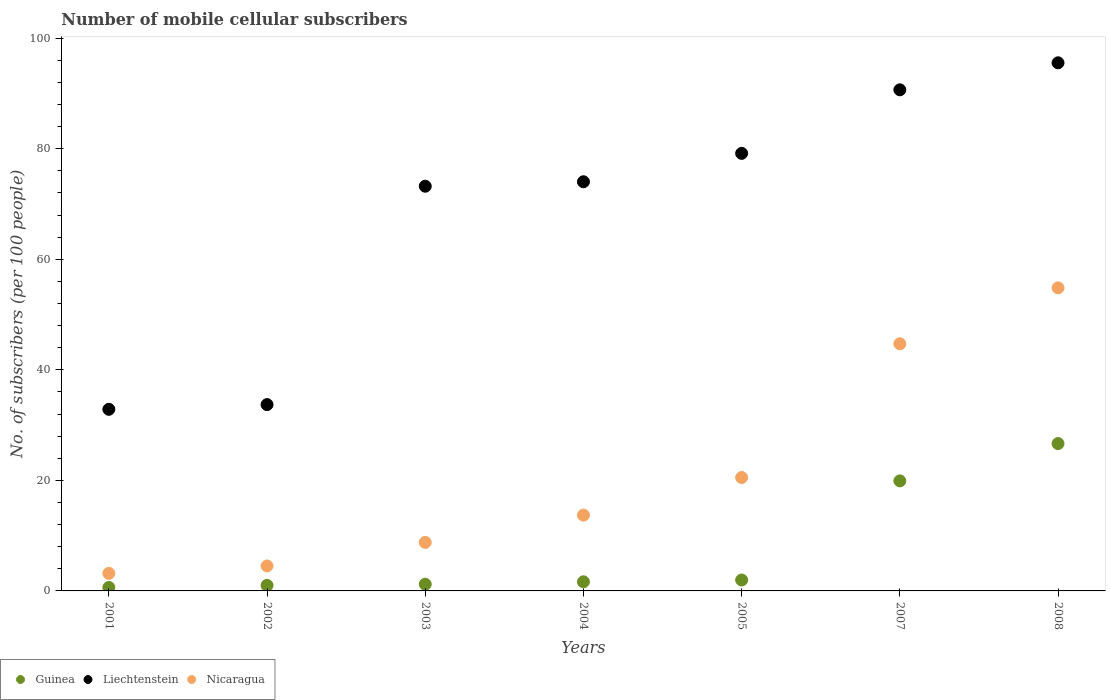How many different coloured dotlines are there?
Keep it short and to the point. 3. What is the number of mobile cellular subscribers in Nicaragua in 2003?
Provide a succinct answer. 8.78. Across all years, what is the maximum number of mobile cellular subscribers in Nicaragua?
Keep it short and to the point. 54.83. Across all years, what is the minimum number of mobile cellular subscribers in Guinea?
Keep it short and to the point. 0.63. What is the total number of mobile cellular subscribers in Liechtenstein in the graph?
Your answer should be compact. 479.22. What is the difference between the number of mobile cellular subscribers in Liechtenstein in 2007 and that in 2008?
Provide a short and direct response. -4.89. What is the difference between the number of mobile cellular subscribers in Nicaragua in 2001 and the number of mobile cellular subscribers in Guinea in 2008?
Offer a very short reply. -23.48. What is the average number of mobile cellular subscribers in Liechtenstein per year?
Your response must be concise. 68.46. In the year 2008, what is the difference between the number of mobile cellular subscribers in Nicaragua and number of mobile cellular subscribers in Guinea?
Your answer should be very brief. 28.17. What is the ratio of the number of mobile cellular subscribers in Guinea in 2003 to that in 2007?
Your answer should be very brief. 0.06. Is the number of mobile cellular subscribers in Guinea in 2002 less than that in 2005?
Ensure brevity in your answer.  Yes. What is the difference between the highest and the second highest number of mobile cellular subscribers in Liechtenstein?
Your answer should be compact. 4.89. What is the difference between the highest and the lowest number of mobile cellular subscribers in Guinea?
Provide a short and direct response. 26.04. Is it the case that in every year, the sum of the number of mobile cellular subscribers in Liechtenstein and number of mobile cellular subscribers in Nicaragua  is greater than the number of mobile cellular subscribers in Guinea?
Ensure brevity in your answer.  Yes. Does the number of mobile cellular subscribers in Guinea monotonically increase over the years?
Your answer should be compact. Yes. Is the number of mobile cellular subscribers in Liechtenstein strictly greater than the number of mobile cellular subscribers in Guinea over the years?
Offer a very short reply. Yes. How many years are there in the graph?
Provide a short and direct response. 7. What is the difference between two consecutive major ticks on the Y-axis?
Provide a short and direct response. 20. Are the values on the major ticks of Y-axis written in scientific E-notation?
Keep it short and to the point. No. Does the graph contain grids?
Provide a succinct answer. No. Where does the legend appear in the graph?
Ensure brevity in your answer.  Bottom left. How many legend labels are there?
Your answer should be compact. 3. How are the legend labels stacked?
Offer a very short reply. Horizontal. What is the title of the graph?
Offer a terse response. Number of mobile cellular subscribers. Does "Peru" appear as one of the legend labels in the graph?
Give a very brief answer. No. What is the label or title of the X-axis?
Provide a succinct answer. Years. What is the label or title of the Y-axis?
Your answer should be compact. No. of subscribers (per 100 people). What is the No. of subscribers (per 100 people) in Guinea in 2001?
Your answer should be very brief. 0.63. What is the No. of subscribers (per 100 people) of Liechtenstein in 2001?
Your response must be concise. 32.86. What is the No. of subscribers (per 100 people) in Nicaragua in 2001?
Your answer should be compact. 3.18. What is the No. of subscribers (per 100 people) of Guinea in 2002?
Provide a succinct answer. 1. What is the No. of subscribers (per 100 people) in Liechtenstein in 2002?
Offer a very short reply. 33.71. What is the No. of subscribers (per 100 people) of Nicaragua in 2002?
Your response must be concise. 4.52. What is the No. of subscribers (per 100 people) of Guinea in 2003?
Provide a succinct answer. 1.21. What is the No. of subscribers (per 100 people) of Liechtenstein in 2003?
Offer a very short reply. 73.23. What is the No. of subscribers (per 100 people) of Nicaragua in 2003?
Your response must be concise. 8.78. What is the No. of subscribers (per 100 people) in Guinea in 2004?
Offer a very short reply. 1.65. What is the No. of subscribers (per 100 people) in Liechtenstein in 2004?
Offer a terse response. 74.03. What is the No. of subscribers (per 100 people) in Nicaragua in 2004?
Make the answer very short. 13.71. What is the No. of subscribers (per 100 people) of Guinea in 2005?
Make the answer very short. 1.97. What is the No. of subscribers (per 100 people) of Liechtenstein in 2005?
Your answer should be very brief. 79.17. What is the No. of subscribers (per 100 people) of Nicaragua in 2005?
Ensure brevity in your answer.  20.52. What is the No. of subscribers (per 100 people) of Guinea in 2007?
Make the answer very short. 19.91. What is the No. of subscribers (per 100 people) in Liechtenstein in 2007?
Your response must be concise. 90.67. What is the No. of subscribers (per 100 people) in Nicaragua in 2007?
Offer a very short reply. 44.72. What is the No. of subscribers (per 100 people) in Guinea in 2008?
Offer a very short reply. 26.66. What is the No. of subscribers (per 100 people) in Liechtenstein in 2008?
Give a very brief answer. 95.55. What is the No. of subscribers (per 100 people) in Nicaragua in 2008?
Provide a succinct answer. 54.83. Across all years, what is the maximum No. of subscribers (per 100 people) of Guinea?
Offer a terse response. 26.66. Across all years, what is the maximum No. of subscribers (per 100 people) of Liechtenstein?
Provide a short and direct response. 95.55. Across all years, what is the maximum No. of subscribers (per 100 people) of Nicaragua?
Ensure brevity in your answer.  54.83. Across all years, what is the minimum No. of subscribers (per 100 people) of Guinea?
Ensure brevity in your answer.  0.63. Across all years, what is the minimum No. of subscribers (per 100 people) in Liechtenstein?
Make the answer very short. 32.86. Across all years, what is the minimum No. of subscribers (per 100 people) in Nicaragua?
Provide a short and direct response. 3.18. What is the total No. of subscribers (per 100 people) of Guinea in the graph?
Your answer should be compact. 53.03. What is the total No. of subscribers (per 100 people) in Liechtenstein in the graph?
Provide a succinct answer. 479.22. What is the total No. of subscribers (per 100 people) of Nicaragua in the graph?
Keep it short and to the point. 150.26. What is the difference between the No. of subscribers (per 100 people) in Guinea in 2001 and that in 2002?
Your answer should be very brief. -0.38. What is the difference between the No. of subscribers (per 100 people) of Liechtenstein in 2001 and that in 2002?
Provide a short and direct response. -0.85. What is the difference between the No. of subscribers (per 100 people) in Nicaragua in 2001 and that in 2002?
Your response must be concise. -1.34. What is the difference between the No. of subscribers (per 100 people) in Guinea in 2001 and that in 2003?
Provide a succinct answer. -0.59. What is the difference between the No. of subscribers (per 100 people) of Liechtenstein in 2001 and that in 2003?
Offer a very short reply. -40.37. What is the difference between the No. of subscribers (per 100 people) in Nicaragua in 2001 and that in 2003?
Ensure brevity in your answer.  -5.6. What is the difference between the No. of subscribers (per 100 people) of Guinea in 2001 and that in 2004?
Make the answer very short. -1.03. What is the difference between the No. of subscribers (per 100 people) in Liechtenstein in 2001 and that in 2004?
Your answer should be compact. -41.17. What is the difference between the No. of subscribers (per 100 people) of Nicaragua in 2001 and that in 2004?
Provide a short and direct response. -10.54. What is the difference between the No. of subscribers (per 100 people) in Guinea in 2001 and that in 2005?
Offer a very short reply. -1.35. What is the difference between the No. of subscribers (per 100 people) in Liechtenstein in 2001 and that in 2005?
Keep it short and to the point. -46.31. What is the difference between the No. of subscribers (per 100 people) of Nicaragua in 2001 and that in 2005?
Offer a very short reply. -17.34. What is the difference between the No. of subscribers (per 100 people) of Guinea in 2001 and that in 2007?
Ensure brevity in your answer.  -19.28. What is the difference between the No. of subscribers (per 100 people) in Liechtenstein in 2001 and that in 2007?
Keep it short and to the point. -57.81. What is the difference between the No. of subscribers (per 100 people) in Nicaragua in 2001 and that in 2007?
Provide a succinct answer. -41.54. What is the difference between the No. of subscribers (per 100 people) in Guinea in 2001 and that in 2008?
Your response must be concise. -26.04. What is the difference between the No. of subscribers (per 100 people) of Liechtenstein in 2001 and that in 2008?
Offer a very short reply. -62.69. What is the difference between the No. of subscribers (per 100 people) in Nicaragua in 2001 and that in 2008?
Make the answer very short. -51.66. What is the difference between the No. of subscribers (per 100 people) in Guinea in 2002 and that in 2003?
Offer a terse response. -0.21. What is the difference between the No. of subscribers (per 100 people) in Liechtenstein in 2002 and that in 2003?
Offer a terse response. -39.51. What is the difference between the No. of subscribers (per 100 people) of Nicaragua in 2002 and that in 2003?
Provide a short and direct response. -4.26. What is the difference between the No. of subscribers (per 100 people) of Guinea in 2002 and that in 2004?
Ensure brevity in your answer.  -0.65. What is the difference between the No. of subscribers (per 100 people) of Liechtenstein in 2002 and that in 2004?
Your answer should be very brief. -40.32. What is the difference between the No. of subscribers (per 100 people) of Nicaragua in 2002 and that in 2004?
Your answer should be compact. -9.19. What is the difference between the No. of subscribers (per 100 people) of Guinea in 2002 and that in 2005?
Make the answer very short. -0.97. What is the difference between the No. of subscribers (per 100 people) in Liechtenstein in 2002 and that in 2005?
Make the answer very short. -45.46. What is the difference between the No. of subscribers (per 100 people) in Nicaragua in 2002 and that in 2005?
Provide a short and direct response. -16. What is the difference between the No. of subscribers (per 100 people) in Guinea in 2002 and that in 2007?
Give a very brief answer. -18.9. What is the difference between the No. of subscribers (per 100 people) in Liechtenstein in 2002 and that in 2007?
Make the answer very short. -56.96. What is the difference between the No. of subscribers (per 100 people) in Nicaragua in 2002 and that in 2007?
Give a very brief answer. -40.2. What is the difference between the No. of subscribers (per 100 people) in Guinea in 2002 and that in 2008?
Your response must be concise. -25.66. What is the difference between the No. of subscribers (per 100 people) in Liechtenstein in 2002 and that in 2008?
Your response must be concise. -61.84. What is the difference between the No. of subscribers (per 100 people) of Nicaragua in 2002 and that in 2008?
Your answer should be compact. -50.31. What is the difference between the No. of subscribers (per 100 people) of Guinea in 2003 and that in 2004?
Provide a short and direct response. -0.44. What is the difference between the No. of subscribers (per 100 people) in Liechtenstein in 2003 and that in 2004?
Provide a succinct answer. -0.81. What is the difference between the No. of subscribers (per 100 people) of Nicaragua in 2003 and that in 2004?
Provide a succinct answer. -4.94. What is the difference between the No. of subscribers (per 100 people) of Guinea in 2003 and that in 2005?
Offer a very short reply. -0.76. What is the difference between the No. of subscribers (per 100 people) in Liechtenstein in 2003 and that in 2005?
Make the answer very short. -5.94. What is the difference between the No. of subscribers (per 100 people) of Nicaragua in 2003 and that in 2005?
Make the answer very short. -11.74. What is the difference between the No. of subscribers (per 100 people) of Guinea in 2003 and that in 2007?
Your response must be concise. -18.7. What is the difference between the No. of subscribers (per 100 people) in Liechtenstein in 2003 and that in 2007?
Your answer should be compact. -17.44. What is the difference between the No. of subscribers (per 100 people) in Nicaragua in 2003 and that in 2007?
Give a very brief answer. -35.94. What is the difference between the No. of subscribers (per 100 people) in Guinea in 2003 and that in 2008?
Make the answer very short. -25.45. What is the difference between the No. of subscribers (per 100 people) in Liechtenstein in 2003 and that in 2008?
Keep it short and to the point. -22.33. What is the difference between the No. of subscribers (per 100 people) in Nicaragua in 2003 and that in 2008?
Offer a very short reply. -46.06. What is the difference between the No. of subscribers (per 100 people) of Guinea in 2004 and that in 2005?
Your answer should be compact. -0.32. What is the difference between the No. of subscribers (per 100 people) in Liechtenstein in 2004 and that in 2005?
Make the answer very short. -5.14. What is the difference between the No. of subscribers (per 100 people) in Nicaragua in 2004 and that in 2005?
Offer a terse response. -6.81. What is the difference between the No. of subscribers (per 100 people) in Guinea in 2004 and that in 2007?
Provide a succinct answer. -18.26. What is the difference between the No. of subscribers (per 100 people) of Liechtenstein in 2004 and that in 2007?
Give a very brief answer. -16.64. What is the difference between the No. of subscribers (per 100 people) in Nicaragua in 2004 and that in 2007?
Your answer should be compact. -31.01. What is the difference between the No. of subscribers (per 100 people) of Guinea in 2004 and that in 2008?
Offer a terse response. -25.01. What is the difference between the No. of subscribers (per 100 people) of Liechtenstein in 2004 and that in 2008?
Ensure brevity in your answer.  -21.52. What is the difference between the No. of subscribers (per 100 people) in Nicaragua in 2004 and that in 2008?
Provide a short and direct response. -41.12. What is the difference between the No. of subscribers (per 100 people) of Guinea in 2005 and that in 2007?
Make the answer very short. -17.93. What is the difference between the No. of subscribers (per 100 people) in Liechtenstein in 2005 and that in 2007?
Give a very brief answer. -11.5. What is the difference between the No. of subscribers (per 100 people) of Nicaragua in 2005 and that in 2007?
Your response must be concise. -24.2. What is the difference between the No. of subscribers (per 100 people) of Guinea in 2005 and that in 2008?
Give a very brief answer. -24.69. What is the difference between the No. of subscribers (per 100 people) of Liechtenstein in 2005 and that in 2008?
Offer a very short reply. -16.39. What is the difference between the No. of subscribers (per 100 people) of Nicaragua in 2005 and that in 2008?
Provide a short and direct response. -34.31. What is the difference between the No. of subscribers (per 100 people) in Guinea in 2007 and that in 2008?
Make the answer very short. -6.75. What is the difference between the No. of subscribers (per 100 people) in Liechtenstein in 2007 and that in 2008?
Ensure brevity in your answer.  -4.89. What is the difference between the No. of subscribers (per 100 people) in Nicaragua in 2007 and that in 2008?
Keep it short and to the point. -10.12. What is the difference between the No. of subscribers (per 100 people) in Guinea in 2001 and the No. of subscribers (per 100 people) in Liechtenstein in 2002?
Your answer should be compact. -33.09. What is the difference between the No. of subscribers (per 100 people) in Guinea in 2001 and the No. of subscribers (per 100 people) in Nicaragua in 2002?
Your response must be concise. -3.89. What is the difference between the No. of subscribers (per 100 people) in Liechtenstein in 2001 and the No. of subscribers (per 100 people) in Nicaragua in 2002?
Make the answer very short. 28.34. What is the difference between the No. of subscribers (per 100 people) in Guinea in 2001 and the No. of subscribers (per 100 people) in Liechtenstein in 2003?
Your answer should be very brief. -72.6. What is the difference between the No. of subscribers (per 100 people) of Guinea in 2001 and the No. of subscribers (per 100 people) of Nicaragua in 2003?
Provide a short and direct response. -8.15. What is the difference between the No. of subscribers (per 100 people) in Liechtenstein in 2001 and the No. of subscribers (per 100 people) in Nicaragua in 2003?
Provide a short and direct response. 24.08. What is the difference between the No. of subscribers (per 100 people) in Guinea in 2001 and the No. of subscribers (per 100 people) in Liechtenstein in 2004?
Provide a short and direct response. -73.41. What is the difference between the No. of subscribers (per 100 people) of Guinea in 2001 and the No. of subscribers (per 100 people) of Nicaragua in 2004?
Your response must be concise. -13.09. What is the difference between the No. of subscribers (per 100 people) in Liechtenstein in 2001 and the No. of subscribers (per 100 people) in Nicaragua in 2004?
Give a very brief answer. 19.15. What is the difference between the No. of subscribers (per 100 people) of Guinea in 2001 and the No. of subscribers (per 100 people) of Liechtenstein in 2005?
Provide a short and direct response. -78.54. What is the difference between the No. of subscribers (per 100 people) of Guinea in 2001 and the No. of subscribers (per 100 people) of Nicaragua in 2005?
Provide a succinct answer. -19.89. What is the difference between the No. of subscribers (per 100 people) in Liechtenstein in 2001 and the No. of subscribers (per 100 people) in Nicaragua in 2005?
Ensure brevity in your answer.  12.34. What is the difference between the No. of subscribers (per 100 people) of Guinea in 2001 and the No. of subscribers (per 100 people) of Liechtenstein in 2007?
Keep it short and to the point. -90.04. What is the difference between the No. of subscribers (per 100 people) in Guinea in 2001 and the No. of subscribers (per 100 people) in Nicaragua in 2007?
Your answer should be very brief. -44.09. What is the difference between the No. of subscribers (per 100 people) in Liechtenstein in 2001 and the No. of subscribers (per 100 people) in Nicaragua in 2007?
Keep it short and to the point. -11.86. What is the difference between the No. of subscribers (per 100 people) of Guinea in 2001 and the No. of subscribers (per 100 people) of Liechtenstein in 2008?
Your answer should be very brief. -94.93. What is the difference between the No. of subscribers (per 100 people) of Guinea in 2001 and the No. of subscribers (per 100 people) of Nicaragua in 2008?
Make the answer very short. -54.21. What is the difference between the No. of subscribers (per 100 people) of Liechtenstein in 2001 and the No. of subscribers (per 100 people) of Nicaragua in 2008?
Your answer should be compact. -21.97. What is the difference between the No. of subscribers (per 100 people) of Guinea in 2002 and the No. of subscribers (per 100 people) of Liechtenstein in 2003?
Your response must be concise. -72.22. What is the difference between the No. of subscribers (per 100 people) of Guinea in 2002 and the No. of subscribers (per 100 people) of Nicaragua in 2003?
Offer a very short reply. -7.77. What is the difference between the No. of subscribers (per 100 people) in Liechtenstein in 2002 and the No. of subscribers (per 100 people) in Nicaragua in 2003?
Offer a very short reply. 24.94. What is the difference between the No. of subscribers (per 100 people) of Guinea in 2002 and the No. of subscribers (per 100 people) of Liechtenstein in 2004?
Give a very brief answer. -73.03. What is the difference between the No. of subscribers (per 100 people) of Guinea in 2002 and the No. of subscribers (per 100 people) of Nicaragua in 2004?
Offer a terse response. -12.71. What is the difference between the No. of subscribers (per 100 people) of Liechtenstein in 2002 and the No. of subscribers (per 100 people) of Nicaragua in 2004?
Offer a very short reply. 20. What is the difference between the No. of subscribers (per 100 people) of Guinea in 2002 and the No. of subscribers (per 100 people) of Liechtenstein in 2005?
Offer a very short reply. -78.16. What is the difference between the No. of subscribers (per 100 people) in Guinea in 2002 and the No. of subscribers (per 100 people) in Nicaragua in 2005?
Keep it short and to the point. -19.52. What is the difference between the No. of subscribers (per 100 people) in Liechtenstein in 2002 and the No. of subscribers (per 100 people) in Nicaragua in 2005?
Offer a terse response. 13.19. What is the difference between the No. of subscribers (per 100 people) in Guinea in 2002 and the No. of subscribers (per 100 people) in Liechtenstein in 2007?
Provide a succinct answer. -89.66. What is the difference between the No. of subscribers (per 100 people) of Guinea in 2002 and the No. of subscribers (per 100 people) of Nicaragua in 2007?
Provide a short and direct response. -43.72. What is the difference between the No. of subscribers (per 100 people) in Liechtenstein in 2002 and the No. of subscribers (per 100 people) in Nicaragua in 2007?
Offer a very short reply. -11.01. What is the difference between the No. of subscribers (per 100 people) in Guinea in 2002 and the No. of subscribers (per 100 people) in Liechtenstein in 2008?
Your response must be concise. -94.55. What is the difference between the No. of subscribers (per 100 people) of Guinea in 2002 and the No. of subscribers (per 100 people) of Nicaragua in 2008?
Ensure brevity in your answer.  -53.83. What is the difference between the No. of subscribers (per 100 people) of Liechtenstein in 2002 and the No. of subscribers (per 100 people) of Nicaragua in 2008?
Keep it short and to the point. -21.12. What is the difference between the No. of subscribers (per 100 people) of Guinea in 2003 and the No. of subscribers (per 100 people) of Liechtenstein in 2004?
Your response must be concise. -72.82. What is the difference between the No. of subscribers (per 100 people) of Guinea in 2003 and the No. of subscribers (per 100 people) of Nicaragua in 2004?
Offer a very short reply. -12.5. What is the difference between the No. of subscribers (per 100 people) of Liechtenstein in 2003 and the No. of subscribers (per 100 people) of Nicaragua in 2004?
Your response must be concise. 59.51. What is the difference between the No. of subscribers (per 100 people) in Guinea in 2003 and the No. of subscribers (per 100 people) in Liechtenstein in 2005?
Make the answer very short. -77.96. What is the difference between the No. of subscribers (per 100 people) of Guinea in 2003 and the No. of subscribers (per 100 people) of Nicaragua in 2005?
Keep it short and to the point. -19.31. What is the difference between the No. of subscribers (per 100 people) of Liechtenstein in 2003 and the No. of subscribers (per 100 people) of Nicaragua in 2005?
Provide a short and direct response. 52.71. What is the difference between the No. of subscribers (per 100 people) of Guinea in 2003 and the No. of subscribers (per 100 people) of Liechtenstein in 2007?
Offer a very short reply. -89.46. What is the difference between the No. of subscribers (per 100 people) in Guinea in 2003 and the No. of subscribers (per 100 people) in Nicaragua in 2007?
Ensure brevity in your answer.  -43.51. What is the difference between the No. of subscribers (per 100 people) in Liechtenstein in 2003 and the No. of subscribers (per 100 people) in Nicaragua in 2007?
Provide a short and direct response. 28.51. What is the difference between the No. of subscribers (per 100 people) in Guinea in 2003 and the No. of subscribers (per 100 people) in Liechtenstein in 2008?
Make the answer very short. -94.34. What is the difference between the No. of subscribers (per 100 people) of Guinea in 2003 and the No. of subscribers (per 100 people) of Nicaragua in 2008?
Provide a succinct answer. -53.62. What is the difference between the No. of subscribers (per 100 people) of Liechtenstein in 2003 and the No. of subscribers (per 100 people) of Nicaragua in 2008?
Make the answer very short. 18.39. What is the difference between the No. of subscribers (per 100 people) of Guinea in 2004 and the No. of subscribers (per 100 people) of Liechtenstein in 2005?
Ensure brevity in your answer.  -77.52. What is the difference between the No. of subscribers (per 100 people) in Guinea in 2004 and the No. of subscribers (per 100 people) in Nicaragua in 2005?
Your answer should be compact. -18.87. What is the difference between the No. of subscribers (per 100 people) in Liechtenstein in 2004 and the No. of subscribers (per 100 people) in Nicaragua in 2005?
Provide a succinct answer. 53.51. What is the difference between the No. of subscribers (per 100 people) of Guinea in 2004 and the No. of subscribers (per 100 people) of Liechtenstein in 2007?
Keep it short and to the point. -89.02. What is the difference between the No. of subscribers (per 100 people) in Guinea in 2004 and the No. of subscribers (per 100 people) in Nicaragua in 2007?
Keep it short and to the point. -43.07. What is the difference between the No. of subscribers (per 100 people) of Liechtenstein in 2004 and the No. of subscribers (per 100 people) of Nicaragua in 2007?
Ensure brevity in your answer.  29.31. What is the difference between the No. of subscribers (per 100 people) of Guinea in 2004 and the No. of subscribers (per 100 people) of Liechtenstein in 2008?
Your answer should be compact. -93.9. What is the difference between the No. of subscribers (per 100 people) of Guinea in 2004 and the No. of subscribers (per 100 people) of Nicaragua in 2008?
Your answer should be compact. -53.18. What is the difference between the No. of subscribers (per 100 people) in Liechtenstein in 2004 and the No. of subscribers (per 100 people) in Nicaragua in 2008?
Offer a terse response. 19.2. What is the difference between the No. of subscribers (per 100 people) of Guinea in 2005 and the No. of subscribers (per 100 people) of Liechtenstein in 2007?
Your answer should be compact. -88.69. What is the difference between the No. of subscribers (per 100 people) of Guinea in 2005 and the No. of subscribers (per 100 people) of Nicaragua in 2007?
Give a very brief answer. -42.75. What is the difference between the No. of subscribers (per 100 people) of Liechtenstein in 2005 and the No. of subscribers (per 100 people) of Nicaragua in 2007?
Offer a very short reply. 34.45. What is the difference between the No. of subscribers (per 100 people) in Guinea in 2005 and the No. of subscribers (per 100 people) in Liechtenstein in 2008?
Your answer should be compact. -93.58. What is the difference between the No. of subscribers (per 100 people) in Guinea in 2005 and the No. of subscribers (per 100 people) in Nicaragua in 2008?
Ensure brevity in your answer.  -52.86. What is the difference between the No. of subscribers (per 100 people) in Liechtenstein in 2005 and the No. of subscribers (per 100 people) in Nicaragua in 2008?
Give a very brief answer. 24.33. What is the difference between the No. of subscribers (per 100 people) in Guinea in 2007 and the No. of subscribers (per 100 people) in Liechtenstein in 2008?
Ensure brevity in your answer.  -75.65. What is the difference between the No. of subscribers (per 100 people) of Guinea in 2007 and the No. of subscribers (per 100 people) of Nicaragua in 2008?
Ensure brevity in your answer.  -34.93. What is the difference between the No. of subscribers (per 100 people) in Liechtenstein in 2007 and the No. of subscribers (per 100 people) in Nicaragua in 2008?
Make the answer very short. 35.83. What is the average No. of subscribers (per 100 people) in Guinea per year?
Your answer should be very brief. 7.58. What is the average No. of subscribers (per 100 people) in Liechtenstein per year?
Give a very brief answer. 68.46. What is the average No. of subscribers (per 100 people) in Nicaragua per year?
Your response must be concise. 21.47. In the year 2001, what is the difference between the No. of subscribers (per 100 people) of Guinea and No. of subscribers (per 100 people) of Liechtenstein?
Your answer should be very brief. -32.23. In the year 2001, what is the difference between the No. of subscribers (per 100 people) of Guinea and No. of subscribers (per 100 people) of Nicaragua?
Offer a terse response. -2.55. In the year 2001, what is the difference between the No. of subscribers (per 100 people) of Liechtenstein and No. of subscribers (per 100 people) of Nicaragua?
Offer a very short reply. 29.68. In the year 2002, what is the difference between the No. of subscribers (per 100 people) of Guinea and No. of subscribers (per 100 people) of Liechtenstein?
Make the answer very short. -32.71. In the year 2002, what is the difference between the No. of subscribers (per 100 people) in Guinea and No. of subscribers (per 100 people) in Nicaragua?
Give a very brief answer. -3.52. In the year 2002, what is the difference between the No. of subscribers (per 100 people) of Liechtenstein and No. of subscribers (per 100 people) of Nicaragua?
Ensure brevity in your answer.  29.19. In the year 2003, what is the difference between the No. of subscribers (per 100 people) in Guinea and No. of subscribers (per 100 people) in Liechtenstein?
Provide a short and direct response. -72.01. In the year 2003, what is the difference between the No. of subscribers (per 100 people) in Guinea and No. of subscribers (per 100 people) in Nicaragua?
Give a very brief answer. -7.56. In the year 2003, what is the difference between the No. of subscribers (per 100 people) in Liechtenstein and No. of subscribers (per 100 people) in Nicaragua?
Provide a short and direct response. 64.45. In the year 2004, what is the difference between the No. of subscribers (per 100 people) of Guinea and No. of subscribers (per 100 people) of Liechtenstein?
Keep it short and to the point. -72.38. In the year 2004, what is the difference between the No. of subscribers (per 100 people) of Guinea and No. of subscribers (per 100 people) of Nicaragua?
Your answer should be compact. -12.06. In the year 2004, what is the difference between the No. of subscribers (per 100 people) in Liechtenstein and No. of subscribers (per 100 people) in Nicaragua?
Give a very brief answer. 60.32. In the year 2005, what is the difference between the No. of subscribers (per 100 people) in Guinea and No. of subscribers (per 100 people) in Liechtenstein?
Your response must be concise. -77.19. In the year 2005, what is the difference between the No. of subscribers (per 100 people) of Guinea and No. of subscribers (per 100 people) of Nicaragua?
Provide a short and direct response. -18.55. In the year 2005, what is the difference between the No. of subscribers (per 100 people) in Liechtenstein and No. of subscribers (per 100 people) in Nicaragua?
Offer a very short reply. 58.65. In the year 2007, what is the difference between the No. of subscribers (per 100 people) in Guinea and No. of subscribers (per 100 people) in Liechtenstein?
Your response must be concise. -70.76. In the year 2007, what is the difference between the No. of subscribers (per 100 people) in Guinea and No. of subscribers (per 100 people) in Nicaragua?
Give a very brief answer. -24.81. In the year 2007, what is the difference between the No. of subscribers (per 100 people) in Liechtenstein and No. of subscribers (per 100 people) in Nicaragua?
Your answer should be very brief. 45.95. In the year 2008, what is the difference between the No. of subscribers (per 100 people) of Guinea and No. of subscribers (per 100 people) of Liechtenstein?
Ensure brevity in your answer.  -68.89. In the year 2008, what is the difference between the No. of subscribers (per 100 people) of Guinea and No. of subscribers (per 100 people) of Nicaragua?
Provide a succinct answer. -28.17. In the year 2008, what is the difference between the No. of subscribers (per 100 people) of Liechtenstein and No. of subscribers (per 100 people) of Nicaragua?
Provide a succinct answer. 40.72. What is the ratio of the No. of subscribers (per 100 people) of Guinea in 2001 to that in 2002?
Your answer should be compact. 0.62. What is the ratio of the No. of subscribers (per 100 people) of Liechtenstein in 2001 to that in 2002?
Ensure brevity in your answer.  0.97. What is the ratio of the No. of subscribers (per 100 people) of Nicaragua in 2001 to that in 2002?
Your response must be concise. 0.7. What is the ratio of the No. of subscribers (per 100 people) in Guinea in 2001 to that in 2003?
Your response must be concise. 0.52. What is the ratio of the No. of subscribers (per 100 people) in Liechtenstein in 2001 to that in 2003?
Give a very brief answer. 0.45. What is the ratio of the No. of subscribers (per 100 people) of Nicaragua in 2001 to that in 2003?
Provide a short and direct response. 0.36. What is the ratio of the No. of subscribers (per 100 people) of Guinea in 2001 to that in 2004?
Your response must be concise. 0.38. What is the ratio of the No. of subscribers (per 100 people) in Liechtenstein in 2001 to that in 2004?
Your answer should be compact. 0.44. What is the ratio of the No. of subscribers (per 100 people) in Nicaragua in 2001 to that in 2004?
Offer a very short reply. 0.23. What is the ratio of the No. of subscribers (per 100 people) of Guinea in 2001 to that in 2005?
Your response must be concise. 0.32. What is the ratio of the No. of subscribers (per 100 people) in Liechtenstein in 2001 to that in 2005?
Provide a succinct answer. 0.42. What is the ratio of the No. of subscribers (per 100 people) of Nicaragua in 2001 to that in 2005?
Provide a short and direct response. 0.15. What is the ratio of the No. of subscribers (per 100 people) in Guinea in 2001 to that in 2007?
Give a very brief answer. 0.03. What is the ratio of the No. of subscribers (per 100 people) in Liechtenstein in 2001 to that in 2007?
Keep it short and to the point. 0.36. What is the ratio of the No. of subscribers (per 100 people) in Nicaragua in 2001 to that in 2007?
Provide a short and direct response. 0.07. What is the ratio of the No. of subscribers (per 100 people) of Guinea in 2001 to that in 2008?
Provide a succinct answer. 0.02. What is the ratio of the No. of subscribers (per 100 people) of Liechtenstein in 2001 to that in 2008?
Make the answer very short. 0.34. What is the ratio of the No. of subscribers (per 100 people) of Nicaragua in 2001 to that in 2008?
Provide a succinct answer. 0.06. What is the ratio of the No. of subscribers (per 100 people) in Guinea in 2002 to that in 2003?
Offer a very short reply. 0.83. What is the ratio of the No. of subscribers (per 100 people) in Liechtenstein in 2002 to that in 2003?
Give a very brief answer. 0.46. What is the ratio of the No. of subscribers (per 100 people) of Nicaragua in 2002 to that in 2003?
Make the answer very short. 0.52. What is the ratio of the No. of subscribers (per 100 people) of Guinea in 2002 to that in 2004?
Make the answer very short. 0.61. What is the ratio of the No. of subscribers (per 100 people) of Liechtenstein in 2002 to that in 2004?
Provide a short and direct response. 0.46. What is the ratio of the No. of subscribers (per 100 people) of Nicaragua in 2002 to that in 2004?
Make the answer very short. 0.33. What is the ratio of the No. of subscribers (per 100 people) in Guinea in 2002 to that in 2005?
Keep it short and to the point. 0.51. What is the ratio of the No. of subscribers (per 100 people) of Liechtenstein in 2002 to that in 2005?
Make the answer very short. 0.43. What is the ratio of the No. of subscribers (per 100 people) of Nicaragua in 2002 to that in 2005?
Offer a terse response. 0.22. What is the ratio of the No. of subscribers (per 100 people) of Guinea in 2002 to that in 2007?
Your answer should be very brief. 0.05. What is the ratio of the No. of subscribers (per 100 people) in Liechtenstein in 2002 to that in 2007?
Ensure brevity in your answer.  0.37. What is the ratio of the No. of subscribers (per 100 people) in Nicaragua in 2002 to that in 2007?
Provide a succinct answer. 0.1. What is the ratio of the No. of subscribers (per 100 people) in Guinea in 2002 to that in 2008?
Your answer should be compact. 0.04. What is the ratio of the No. of subscribers (per 100 people) of Liechtenstein in 2002 to that in 2008?
Your answer should be very brief. 0.35. What is the ratio of the No. of subscribers (per 100 people) of Nicaragua in 2002 to that in 2008?
Keep it short and to the point. 0.08. What is the ratio of the No. of subscribers (per 100 people) in Guinea in 2003 to that in 2004?
Give a very brief answer. 0.73. What is the ratio of the No. of subscribers (per 100 people) of Liechtenstein in 2003 to that in 2004?
Ensure brevity in your answer.  0.99. What is the ratio of the No. of subscribers (per 100 people) in Nicaragua in 2003 to that in 2004?
Ensure brevity in your answer.  0.64. What is the ratio of the No. of subscribers (per 100 people) of Guinea in 2003 to that in 2005?
Make the answer very short. 0.61. What is the ratio of the No. of subscribers (per 100 people) of Liechtenstein in 2003 to that in 2005?
Keep it short and to the point. 0.92. What is the ratio of the No. of subscribers (per 100 people) of Nicaragua in 2003 to that in 2005?
Offer a very short reply. 0.43. What is the ratio of the No. of subscribers (per 100 people) in Guinea in 2003 to that in 2007?
Offer a terse response. 0.06. What is the ratio of the No. of subscribers (per 100 people) of Liechtenstein in 2003 to that in 2007?
Offer a terse response. 0.81. What is the ratio of the No. of subscribers (per 100 people) of Nicaragua in 2003 to that in 2007?
Your answer should be very brief. 0.2. What is the ratio of the No. of subscribers (per 100 people) of Guinea in 2003 to that in 2008?
Make the answer very short. 0.05. What is the ratio of the No. of subscribers (per 100 people) in Liechtenstein in 2003 to that in 2008?
Give a very brief answer. 0.77. What is the ratio of the No. of subscribers (per 100 people) of Nicaragua in 2003 to that in 2008?
Offer a terse response. 0.16. What is the ratio of the No. of subscribers (per 100 people) in Guinea in 2004 to that in 2005?
Your response must be concise. 0.84. What is the ratio of the No. of subscribers (per 100 people) in Liechtenstein in 2004 to that in 2005?
Provide a short and direct response. 0.94. What is the ratio of the No. of subscribers (per 100 people) in Nicaragua in 2004 to that in 2005?
Provide a short and direct response. 0.67. What is the ratio of the No. of subscribers (per 100 people) in Guinea in 2004 to that in 2007?
Offer a terse response. 0.08. What is the ratio of the No. of subscribers (per 100 people) in Liechtenstein in 2004 to that in 2007?
Your answer should be compact. 0.82. What is the ratio of the No. of subscribers (per 100 people) of Nicaragua in 2004 to that in 2007?
Your answer should be compact. 0.31. What is the ratio of the No. of subscribers (per 100 people) in Guinea in 2004 to that in 2008?
Offer a terse response. 0.06. What is the ratio of the No. of subscribers (per 100 people) of Liechtenstein in 2004 to that in 2008?
Your answer should be very brief. 0.77. What is the ratio of the No. of subscribers (per 100 people) of Nicaragua in 2004 to that in 2008?
Your response must be concise. 0.25. What is the ratio of the No. of subscribers (per 100 people) in Guinea in 2005 to that in 2007?
Offer a terse response. 0.1. What is the ratio of the No. of subscribers (per 100 people) of Liechtenstein in 2005 to that in 2007?
Provide a succinct answer. 0.87. What is the ratio of the No. of subscribers (per 100 people) in Nicaragua in 2005 to that in 2007?
Offer a very short reply. 0.46. What is the ratio of the No. of subscribers (per 100 people) of Guinea in 2005 to that in 2008?
Your answer should be compact. 0.07. What is the ratio of the No. of subscribers (per 100 people) of Liechtenstein in 2005 to that in 2008?
Give a very brief answer. 0.83. What is the ratio of the No. of subscribers (per 100 people) of Nicaragua in 2005 to that in 2008?
Provide a succinct answer. 0.37. What is the ratio of the No. of subscribers (per 100 people) of Guinea in 2007 to that in 2008?
Your response must be concise. 0.75. What is the ratio of the No. of subscribers (per 100 people) in Liechtenstein in 2007 to that in 2008?
Your answer should be compact. 0.95. What is the ratio of the No. of subscribers (per 100 people) in Nicaragua in 2007 to that in 2008?
Your answer should be very brief. 0.82. What is the difference between the highest and the second highest No. of subscribers (per 100 people) in Guinea?
Make the answer very short. 6.75. What is the difference between the highest and the second highest No. of subscribers (per 100 people) in Liechtenstein?
Your response must be concise. 4.89. What is the difference between the highest and the second highest No. of subscribers (per 100 people) of Nicaragua?
Make the answer very short. 10.12. What is the difference between the highest and the lowest No. of subscribers (per 100 people) in Guinea?
Your answer should be very brief. 26.04. What is the difference between the highest and the lowest No. of subscribers (per 100 people) in Liechtenstein?
Make the answer very short. 62.69. What is the difference between the highest and the lowest No. of subscribers (per 100 people) in Nicaragua?
Offer a terse response. 51.66. 